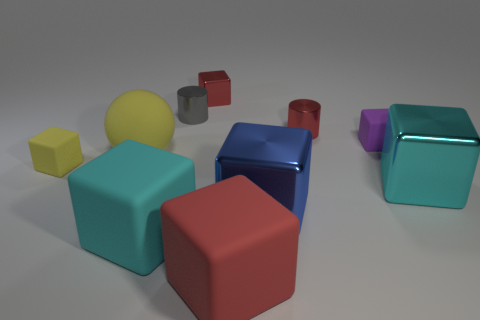Are the tiny purple thing that is in front of the tiny gray cylinder and the red block behind the tiny yellow matte object made of the same material?
Your answer should be very brief. No. Are the red block that is behind the big yellow matte thing and the gray object made of the same material?
Your answer should be compact. Yes. Are there fewer small purple cubes that are in front of the cyan shiny cube than cyan cubes that are right of the small yellow matte cube?
Keep it short and to the point. Yes. What number of other objects are there of the same material as the large sphere?
Make the answer very short. 4. What material is the blue block that is the same size as the red matte object?
Provide a short and direct response. Metal. Are there fewer small purple objects that are in front of the small purple block than big cubes?
Your answer should be very brief. Yes. What is the shape of the small gray metal thing that is to the left of the small matte cube on the right side of the tiny matte object in front of the purple block?
Offer a very short reply. Cylinder. What size is the cyan block that is to the left of the big red matte cube?
Ensure brevity in your answer.  Large. What is the shape of the red object that is the same size as the cyan rubber cube?
Keep it short and to the point. Cube. How many things are red rubber balls or red rubber things that are in front of the blue block?
Provide a succinct answer. 1. 